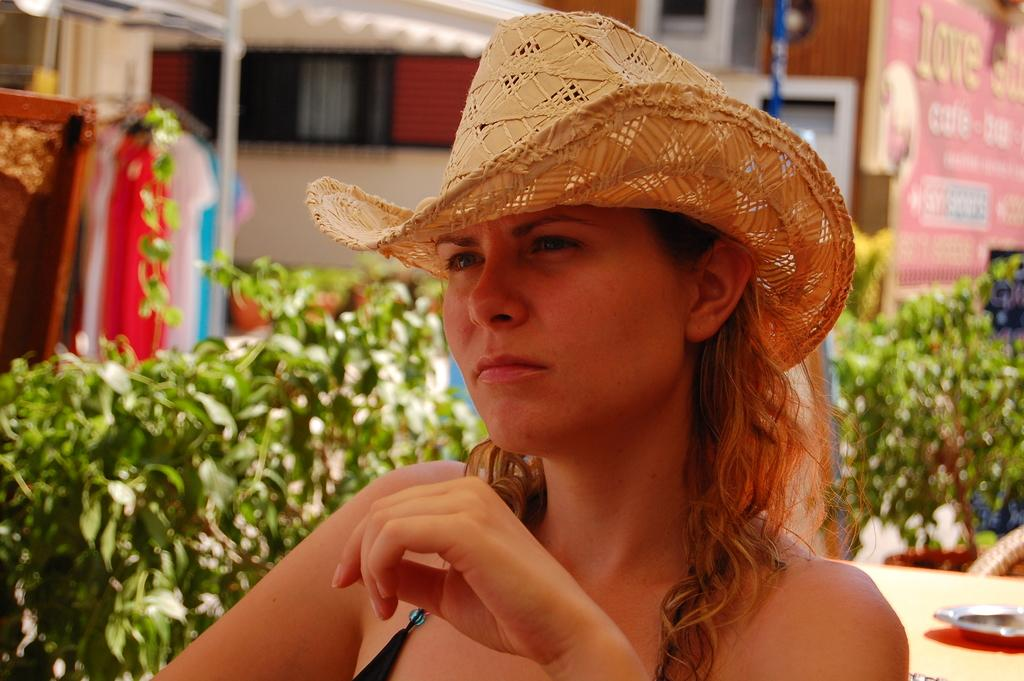Who is the main subject in the foreground of the image? There is a woman in the foreground of the image. What is the woman wearing on her head? The woman is wearing a hat. What can be seen in the background of the image? There are buildings, clothes, pants, and poles present in the background of the image. Can you describe the other objects visible in the background? There are other objects in the background of the image, but their specific details are not mentioned in the provided facts. How does the woman show respect to the form in the image? There is no form present in the image for the woman to show respect to. 